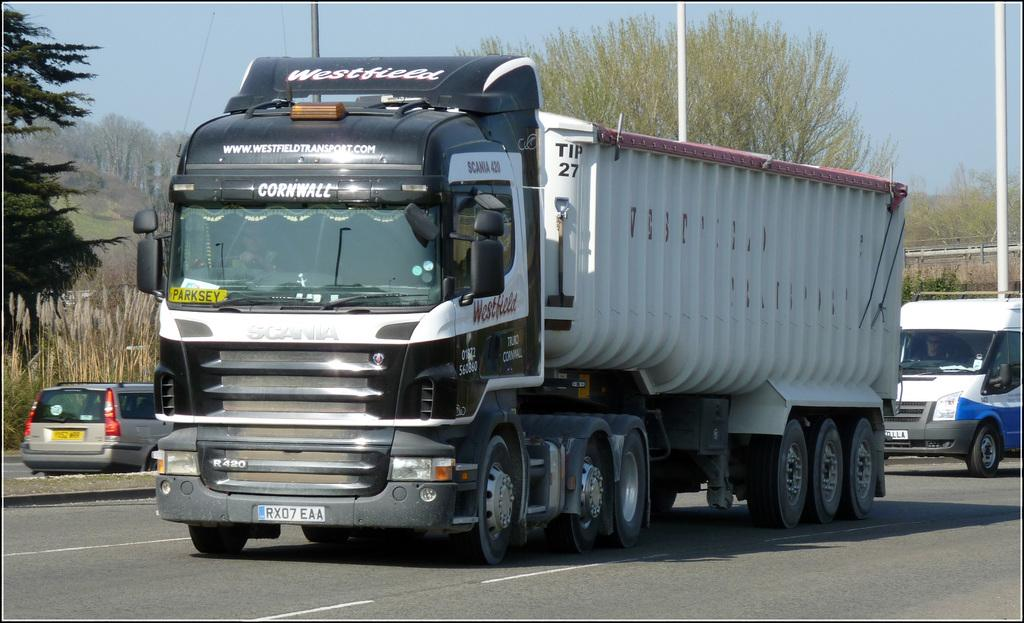What can be seen on the road in the image? There are vehicles on the road in the image. What type of natural environment is visible in the background of the image? There is grass, trees, and the sky visible in the background of the image. What structures can be seen in the background of the image? There are poles in the background of the image. Can you tell me how many yaks are grazing on the grass in the image? There are no yaks present in the image; it features vehicles on the road and natural elements in the background. What type of creature is shown interacting with the vehicles on the road in the image? There is no creature shown interacting with the vehicles on the road in the image; only the vehicles and background elements are present. 